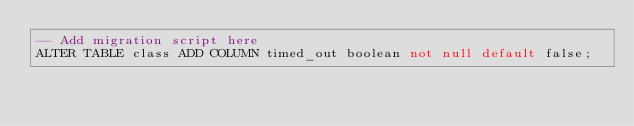Convert code to text. <code><loc_0><loc_0><loc_500><loc_500><_SQL_>-- Add migration script here
ALTER TABLE class ADD COLUMN timed_out boolean not null default false;
</code> 